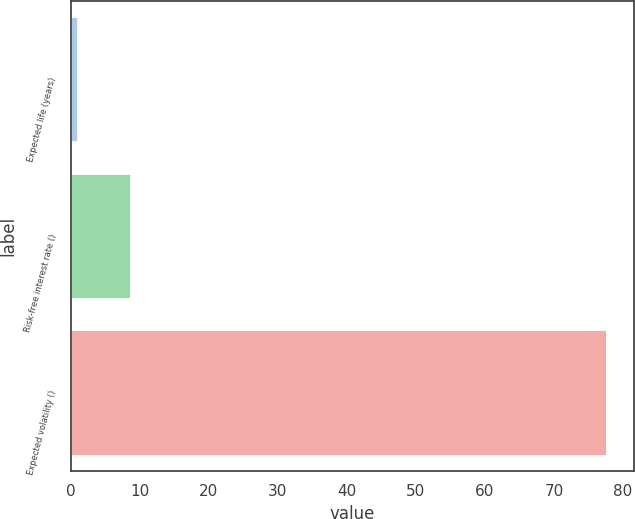Convert chart. <chart><loc_0><loc_0><loc_500><loc_500><bar_chart><fcel>Expected life (years)<fcel>Risk-free interest rate ()<fcel>Expected volatility ()<nl><fcel>1.1<fcel>8.76<fcel>77.7<nl></chart> 